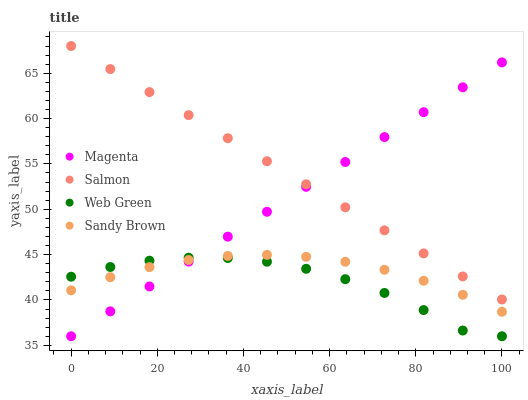Does Web Green have the minimum area under the curve?
Answer yes or no. Yes. Does Salmon have the maximum area under the curve?
Answer yes or no. Yes. Does Magenta have the minimum area under the curve?
Answer yes or no. No. Does Magenta have the maximum area under the curve?
Answer yes or no. No. Is Magenta the smoothest?
Answer yes or no. Yes. Is Web Green the roughest?
Answer yes or no. Yes. Is Salmon the smoothest?
Answer yes or no. No. Is Salmon the roughest?
Answer yes or no. No. Does Magenta have the lowest value?
Answer yes or no. Yes. Does Salmon have the lowest value?
Answer yes or no. No. Does Salmon have the highest value?
Answer yes or no. Yes. Does Magenta have the highest value?
Answer yes or no. No. Is Sandy Brown less than Salmon?
Answer yes or no. Yes. Is Salmon greater than Sandy Brown?
Answer yes or no. Yes. Does Salmon intersect Magenta?
Answer yes or no. Yes. Is Salmon less than Magenta?
Answer yes or no. No. Is Salmon greater than Magenta?
Answer yes or no. No. Does Sandy Brown intersect Salmon?
Answer yes or no. No. 